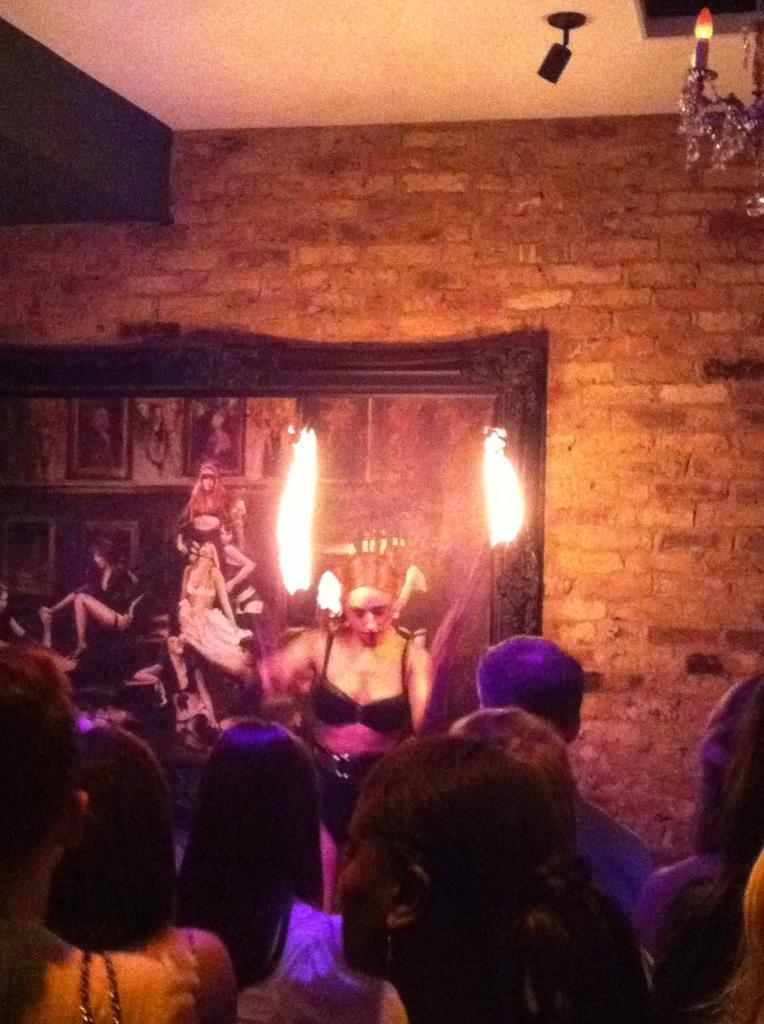Could you give a brief overview of what you see in this image? In this picture we can see a few people from left to right. We can see the lights. There is a frame on a brick wall. In this frame, we can see a few people. There is a chandelier in the top right. 